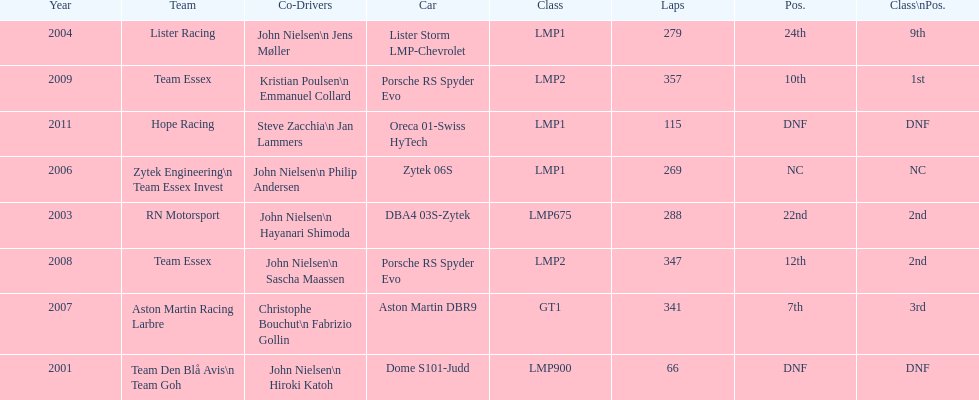In 2008 and what other year was casper elgaard on team essex for the 24 hours of le mans? 2009. 